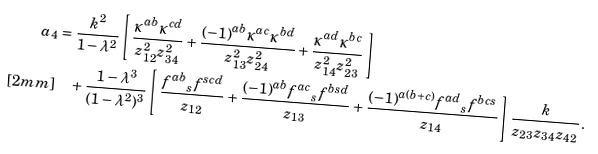<formula> <loc_0><loc_0><loc_500><loc_500>a _ { 4 } & = \frac { k ^ { 2 } } { 1 - \lambda ^ { 2 } } \left [ \, \frac { \kappa ^ { a b } \kappa ^ { c d } } { z _ { 1 2 } ^ { 2 } z _ { 3 4 } ^ { 2 } } + \frac { ( - 1 ) ^ { a b } \kappa ^ { a c } \kappa ^ { b d } } { z _ { 1 3 } ^ { 2 } z _ { 2 4 } ^ { 2 } } + \frac { \kappa ^ { a d } \kappa ^ { b c } } { z _ { 1 4 } ^ { 2 } z _ { 2 3 } ^ { 2 } } \, \right ] \\ [ 2 m m ] & \quad + \frac { 1 - \lambda ^ { 3 } } { ( 1 - \lambda ^ { 2 } ) ^ { 3 } } \left [ \, \frac { { f ^ { a b } } _ { s } f ^ { s c d } } { z _ { 1 2 } } + \frac { ( - 1 ) ^ { a b } { f ^ { a c } } _ { s } f ^ { b s d } } { z _ { 1 3 } } + \frac { ( - 1 ) ^ { a ( b + c ) } { f ^ { a d } } _ { s } f ^ { b c s } } { z _ { 1 4 } } \, \right ] \frac { k } { z _ { 2 3 } z _ { 3 4 } z _ { 4 2 } } \, .</formula> 